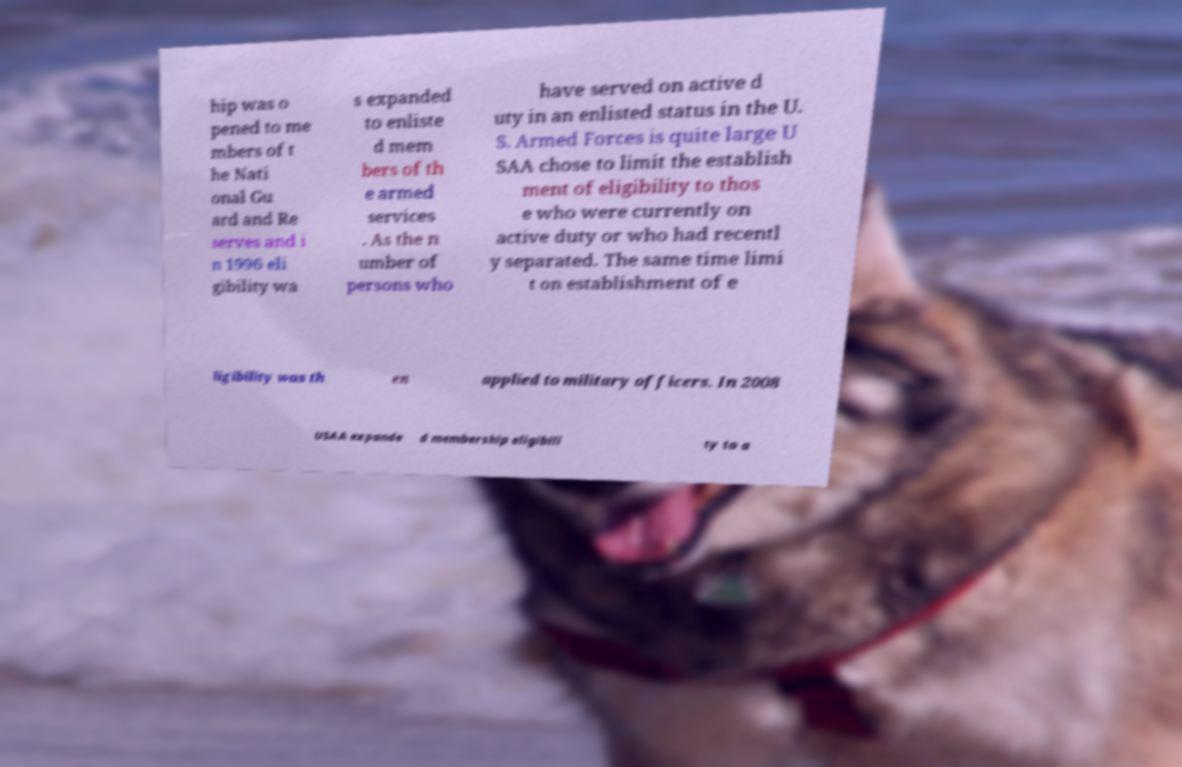Can you read and provide the text displayed in the image?This photo seems to have some interesting text. Can you extract and type it out for me? hip was o pened to me mbers of t he Nati onal Gu ard and Re serves and i n 1996 eli gibility wa s expanded to enliste d mem bers of th e armed services . As the n umber of persons who have served on active d uty in an enlisted status in the U. S. Armed Forces is quite large U SAA chose to limit the establish ment of eligibility to thos e who were currently on active duty or who had recentl y separated. The same time limi t on establishment of e ligibility was th en applied to military officers. In 2008 USAA expande d membership eligibili ty to a 